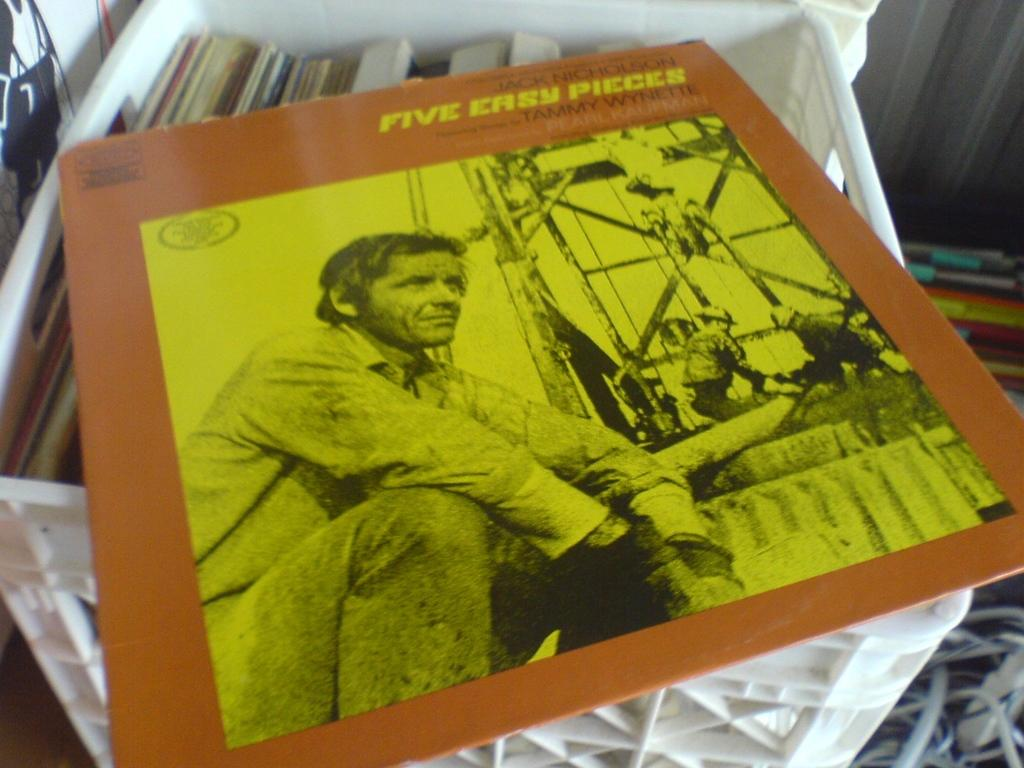Provide a one-sentence caption for the provided image. A Jack Nicholson movie called Five Easy Pieces features songs by Tammy Wynette. 